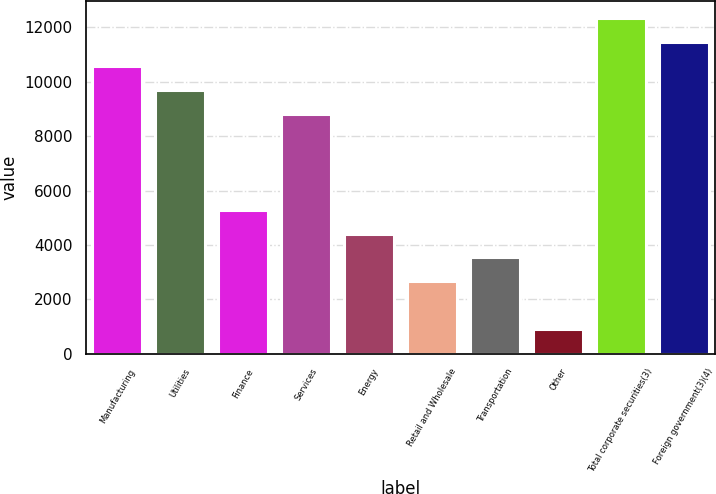<chart> <loc_0><loc_0><loc_500><loc_500><bar_chart><fcel>Manufacturing<fcel>Utilities<fcel>Finance<fcel>Services<fcel>Energy<fcel>Retail and Wholesale<fcel>Transportation<fcel>Other<fcel>Total corporate securities(3)<fcel>Foreign government(3)(4)<nl><fcel>10586.4<fcel>9706.2<fcel>5305.2<fcel>8826<fcel>4425<fcel>2664.6<fcel>3544.8<fcel>904.2<fcel>12346.8<fcel>11466.6<nl></chart> 